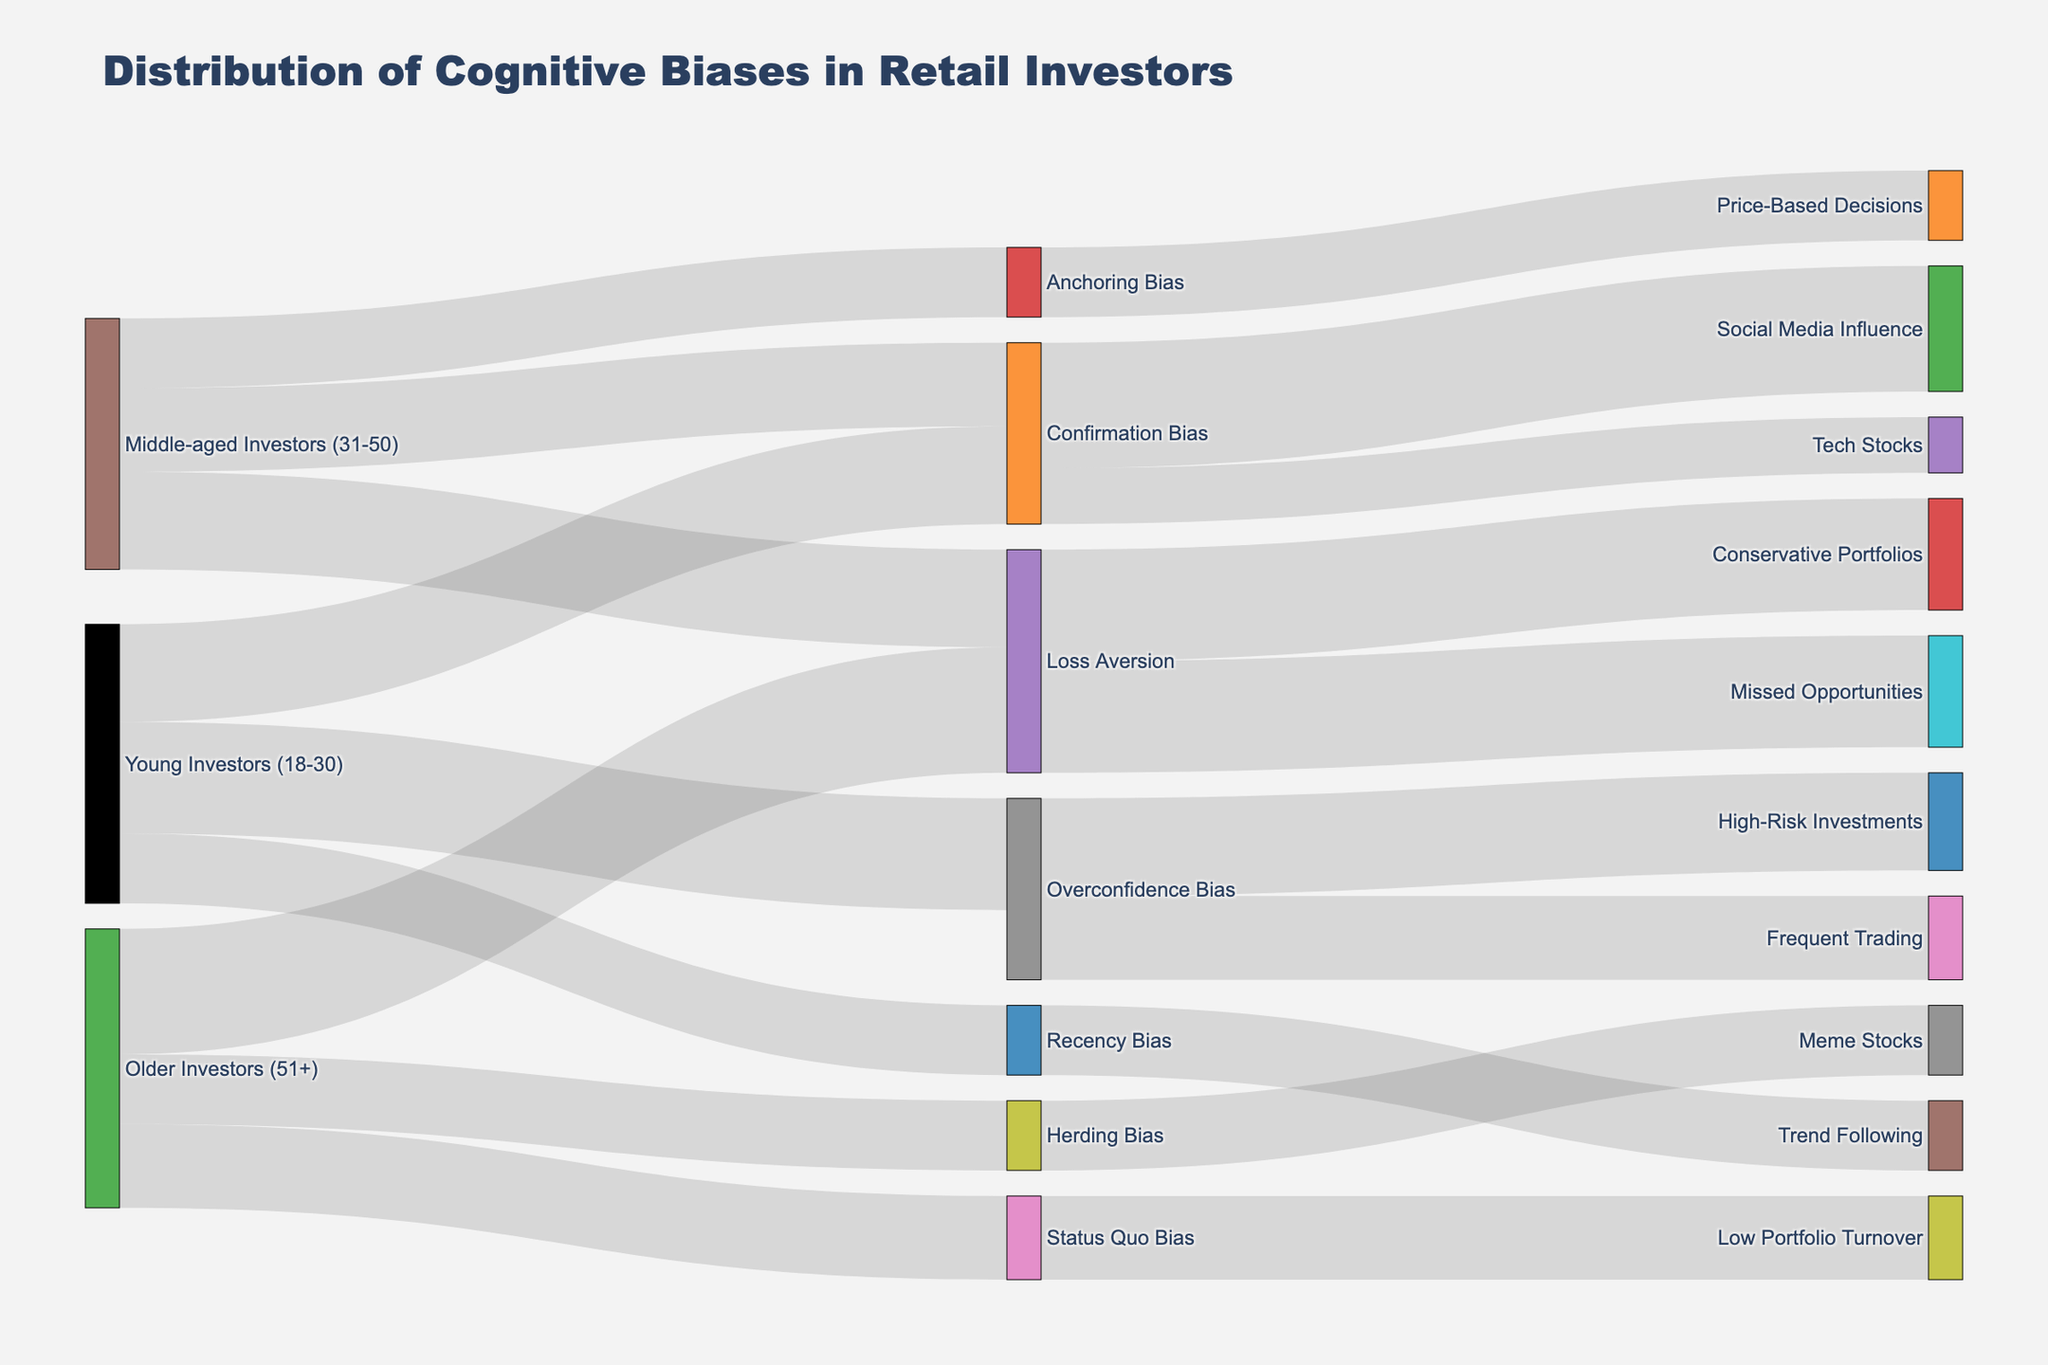Which cognitive bias is most frequently observed among young investors (18-30)? By looking at the links originating from "Young Investors (18-30)", we see the highest value is 40, which corresponds to "Overconfidence Bias".
Answer: Overconfidence Bias Which demographic group exhibits the highest incidence of Loss Aversion? By comparing the value links between "Loss Aversion" and different demographic groups, we see "Older Investors (51+)" has the highest value link of 45.
Answer: Older Investors (51+) What is the total number of incidents of cognitive biases observed in middle-aged investors (31-50)? Sum the values of all biases linked to "Middle-aged Investors (31-50)": 30 (Confirmation Bias) + 35 (Loss Aversion) + 25 (Anchoring Bias) = 90.
Answer: 90 Which outcome is most strongly associated with Confirmation Bias? Among the links originating from "Confirmation Bias", the value 45 is the highest and it targets "Social Media Influence".
Answer: Social Media Influence How does the frequency of Overconfidence Bias in young investors compare to middle-aged investors? "Overconfidence Bias" is not linked to "Middle-aged Investors (31-50)", but it has a value of 40 for "Young Investors (18-30)". Thus, it is only observed in the young investors group.
Answer: More frequent in young investors What is the sum of values for "Loss Aversion" across all demographic groups? Sum the values of "Loss Aversion" observed in different groups: 35 (Middle-aged Investors) + 45 (Older Investors) = 80.
Answer: 80 Which cognitive bias leads to conservative portfolios? The link with "Conservative Portfolios" has a value of 40 and is connected to "Loss Aversion".
Answer: Loss Aversion What is the average value of cognitive biases in young investors (18-30)? Add the values of all biases in young investors and divide by the number of biases: (35 + 40 + 25)/3 = 100/3 ≈ 33.33.
Answer: 33.33 Compare the frequency of "Herding Bias" and "Status Quo Bias" among older investors (51+). From the links originating from "Older Investors (51+)", "Herding Bias" has a value of 25 and "Status Quo Bias" has a value of 30.
Answer: Status Quo Bias is more frequent 